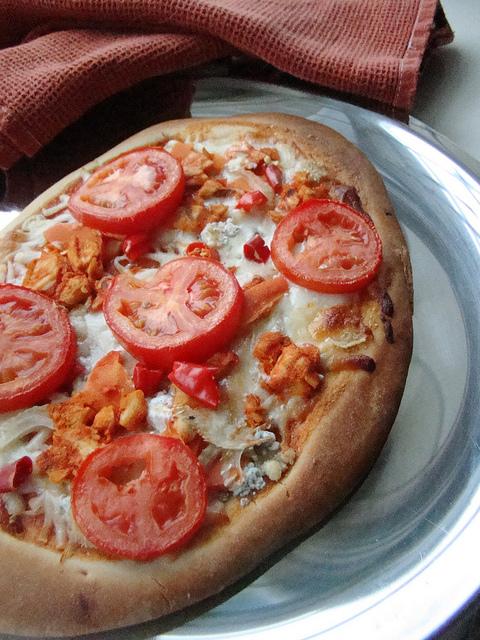What color is the towel?
Short answer required. Red. What is the melted substance on the pizza?
Quick response, please. Cheese. What sliced fruit is on the pizza?
Write a very short answer. Tomato. 